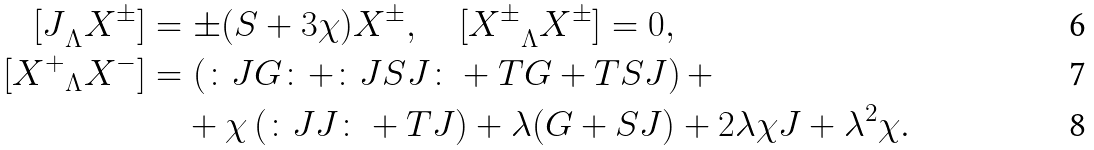Convert formula to latex. <formula><loc_0><loc_0><loc_500><loc_500>{ [ J } _ { \Lambda } X ^ { \pm } ] & = \pm ( S + 3 \chi ) X ^ { \pm } , \quad { [ X ^ { \pm } } _ { \Lambda } X ^ { \pm } ] = 0 , \\ [ { X ^ { + } } _ { \Lambda } X ^ { - } ] & = \left ( \colon J G \colon + \colon J S J \colon + T G + T S J \right ) + \\ & \quad + \chi \left ( \colon J J \colon + T J \right ) + \lambda ( G + S J ) + 2 \lambda \chi J + \lambda ^ { 2 } \chi .</formula> 